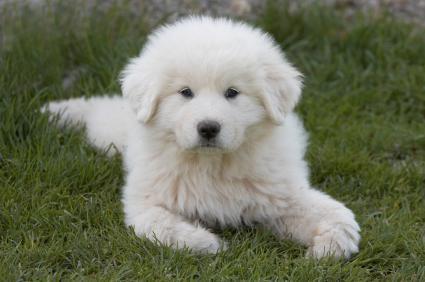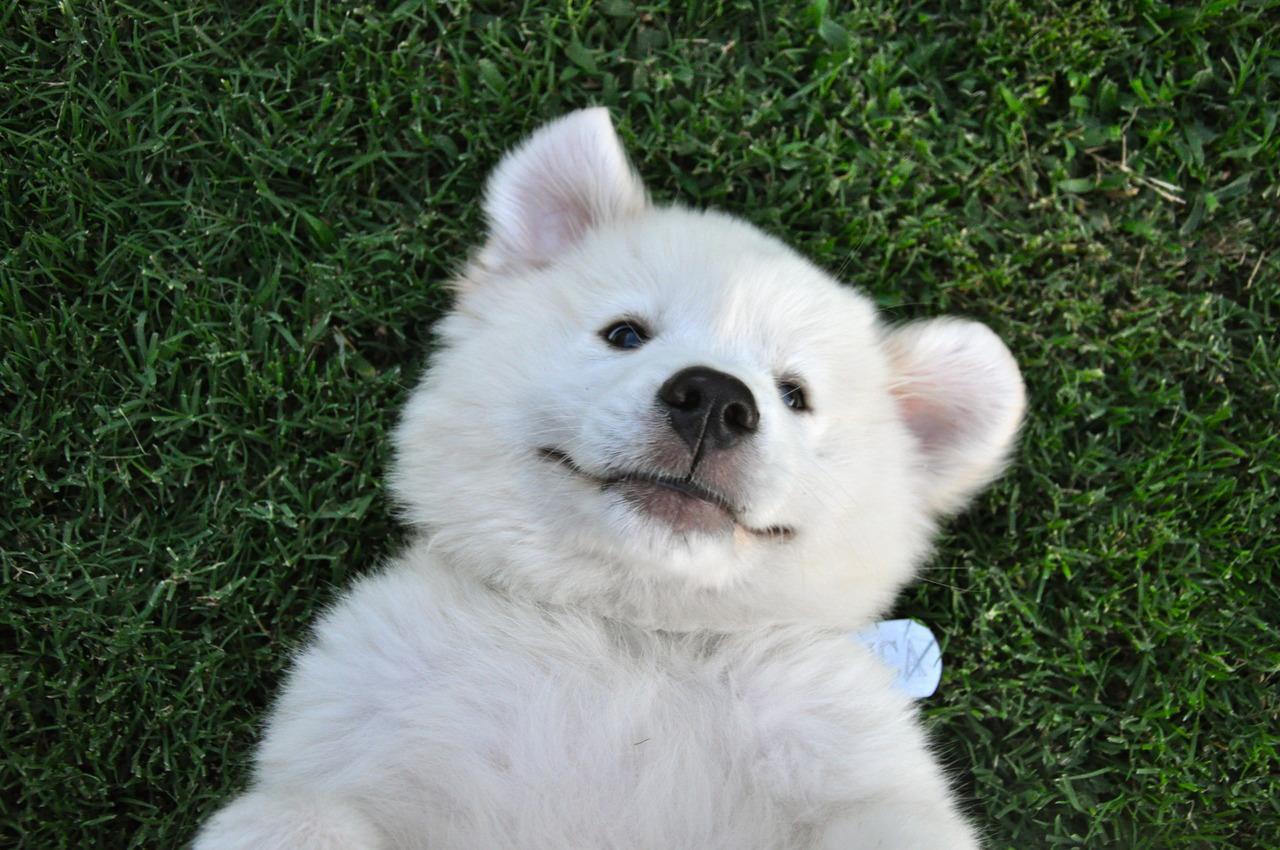The first image is the image on the left, the second image is the image on the right. Analyze the images presented: Is the assertion "At least one dog is standing in the grass." valid? Answer yes or no. No. The first image is the image on the left, the second image is the image on the right. Assess this claim about the two images: "An image shows one big white dog, standing with its head and body turned rightwards.". Correct or not? Answer yes or no. No. 